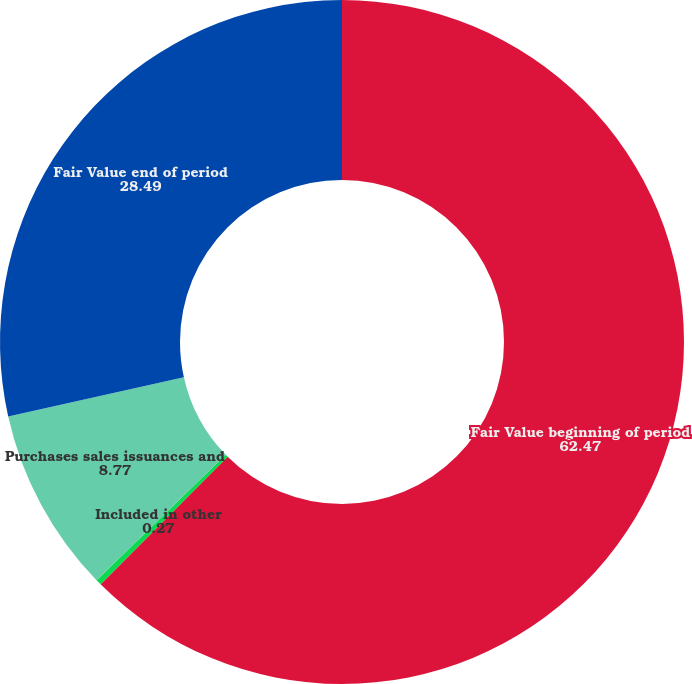Convert chart to OTSL. <chart><loc_0><loc_0><loc_500><loc_500><pie_chart><fcel>Fair Value beginning of period<fcel>Included in other<fcel>Purchases sales issuances and<fcel>Fair Value end of period<nl><fcel>62.47%<fcel>0.27%<fcel>8.77%<fcel>28.49%<nl></chart> 